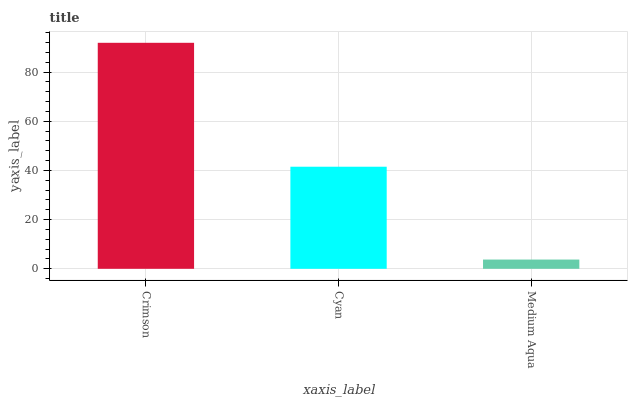Is Medium Aqua the minimum?
Answer yes or no. Yes. Is Crimson the maximum?
Answer yes or no. Yes. Is Cyan the minimum?
Answer yes or no. No. Is Cyan the maximum?
Answer yes or no. No. Is Crimson greater than Cyan?
Answer yes or no. Yes. Is Cyan less than Crimson?
Answer yes or no. Yes. Is Cyan greater than Crimson?
Answer yes or no. No. Is Crimson less than Cyan?
Answer yes or no. No. Is Cyan the high median?
Answer yes or no. Yes. Is Cyan the low median?
Answer yes or no. Yes. Is Medium Aqua the high median?
Answer yes or no. No. Is Crimson the low median?
Answer yes or no. No. 